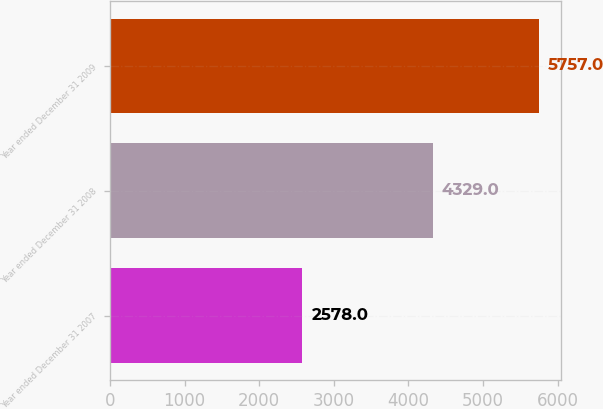Convert chart to OTSL. <chart><loc_0><loc_0><loc_500><loc_500><bar_chart><fcel>Year ended December 31 2007<fcel>Year ended December 31 2008<fcel>Year ended December 31 2009<nl><fcel>2578<fcel>4329<fcel>5757<nl></chart> 